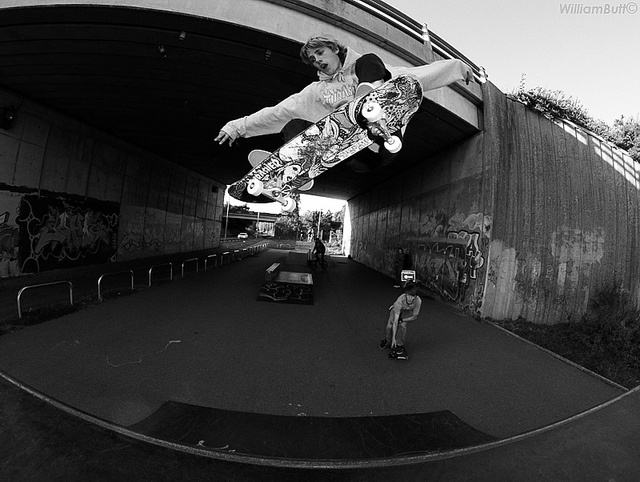Describe the objects in this image and their specific colors. I can see skateboard in darkgray, lightgray, black, and gray tones, people in darkgray, black, lightgray, and gray tones, people in black, gray, and darkgray tones, people in black, gray, and darkgray tones, and skateboard in darkgray, black, gray, and lightgray tones in this image. 